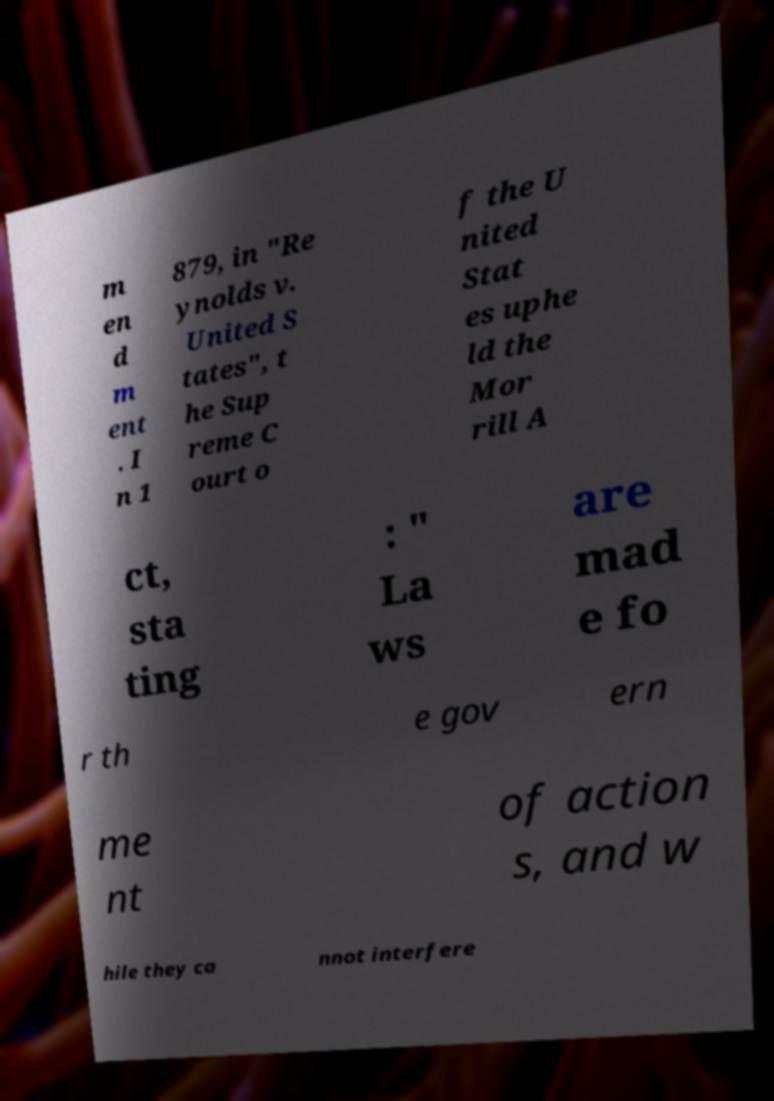Please identify and transcribe the text found in this image. m en d m ent . I n 1 879, in "Re ynolds v. United S tates", t he Sup reme C ourt o f the U nited Stat es uphe ld the Mor rill A ct, sta ting : " La ws are mad e fo r th e gov ern me nt of action s, and w hile they ca nnot interfere 